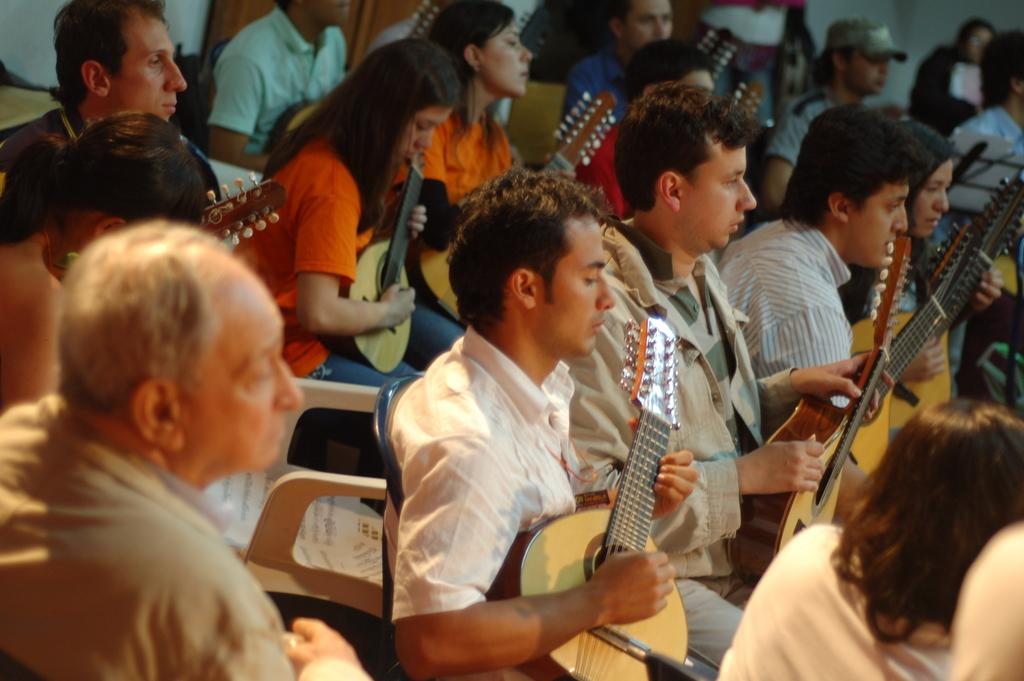What is happening in the image involving the group of people? The people in the image are sitting on chairs and playing guitars. What might be the purpose of the papers with lyrics on one of the chairs? The papers with lyrics might be used as a reference for the songs being played by the people. Can you describe the seating arrangement of the people in the image? The people are sitting on chairs while playing guitars. What type of road can be seen in the image? There is no road present in the image; it features a group of people playing guitars while sitting on chairs. 